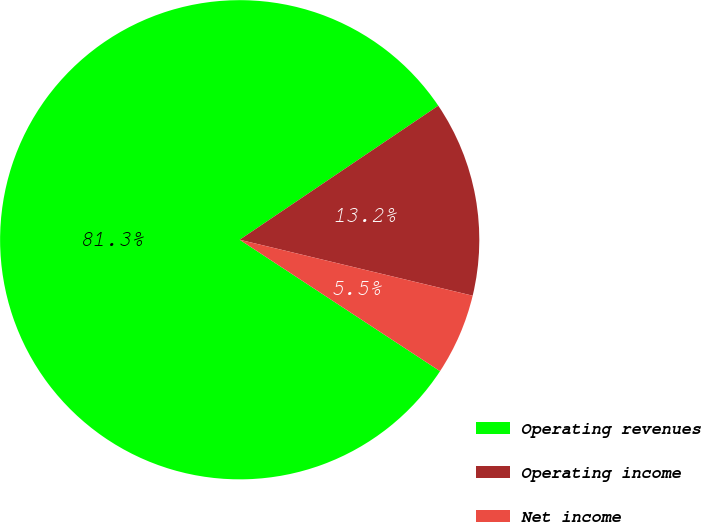Convert chart. <chart><loc_0><loc_0><loc_500><loc_500><pie_chart><fcel>Operating revenues<fcel>Operating income<fcel>Net income<nl><fcel>81.31%<fcel>13.2%<fcel>5.49%<nl></chart> 